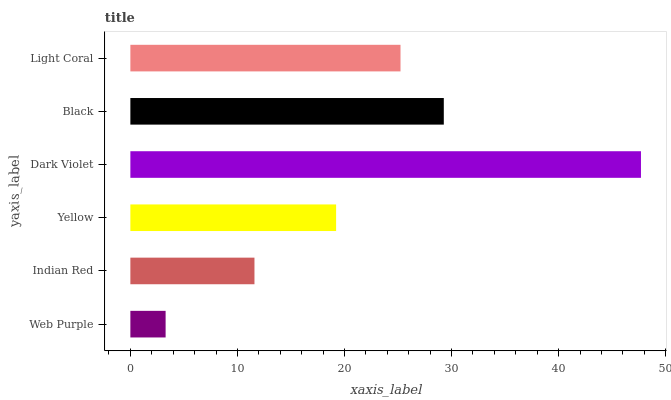Is Web Purple the minimum?
Answer yes or no. Yes. Is Dark Violet the maximum?
Answer yes or no. Yes. Is Indian Red the minimum?
Answer yes or no. No. Is Indian Red the maximum?
Answer yes or no. No. Is Indian Red greater than Web Purple?
Answer yes or no. Yes. Is Web Purple less than Indian Red?
Answer yes or no. Yes. Is Web Purple greater than Indian Red?
Answer yes or no. No. Is Indian Red less than Web Purple?
Answer yes or no. No. Is Light Coral the high median?
Answer yes or no. Yes. Is Yellow the low median?
Answer yes or no. Yes. Is Web Purple the high median?
Answer yes or no. No. Is Black the low median?
Answer yes or no. No. 